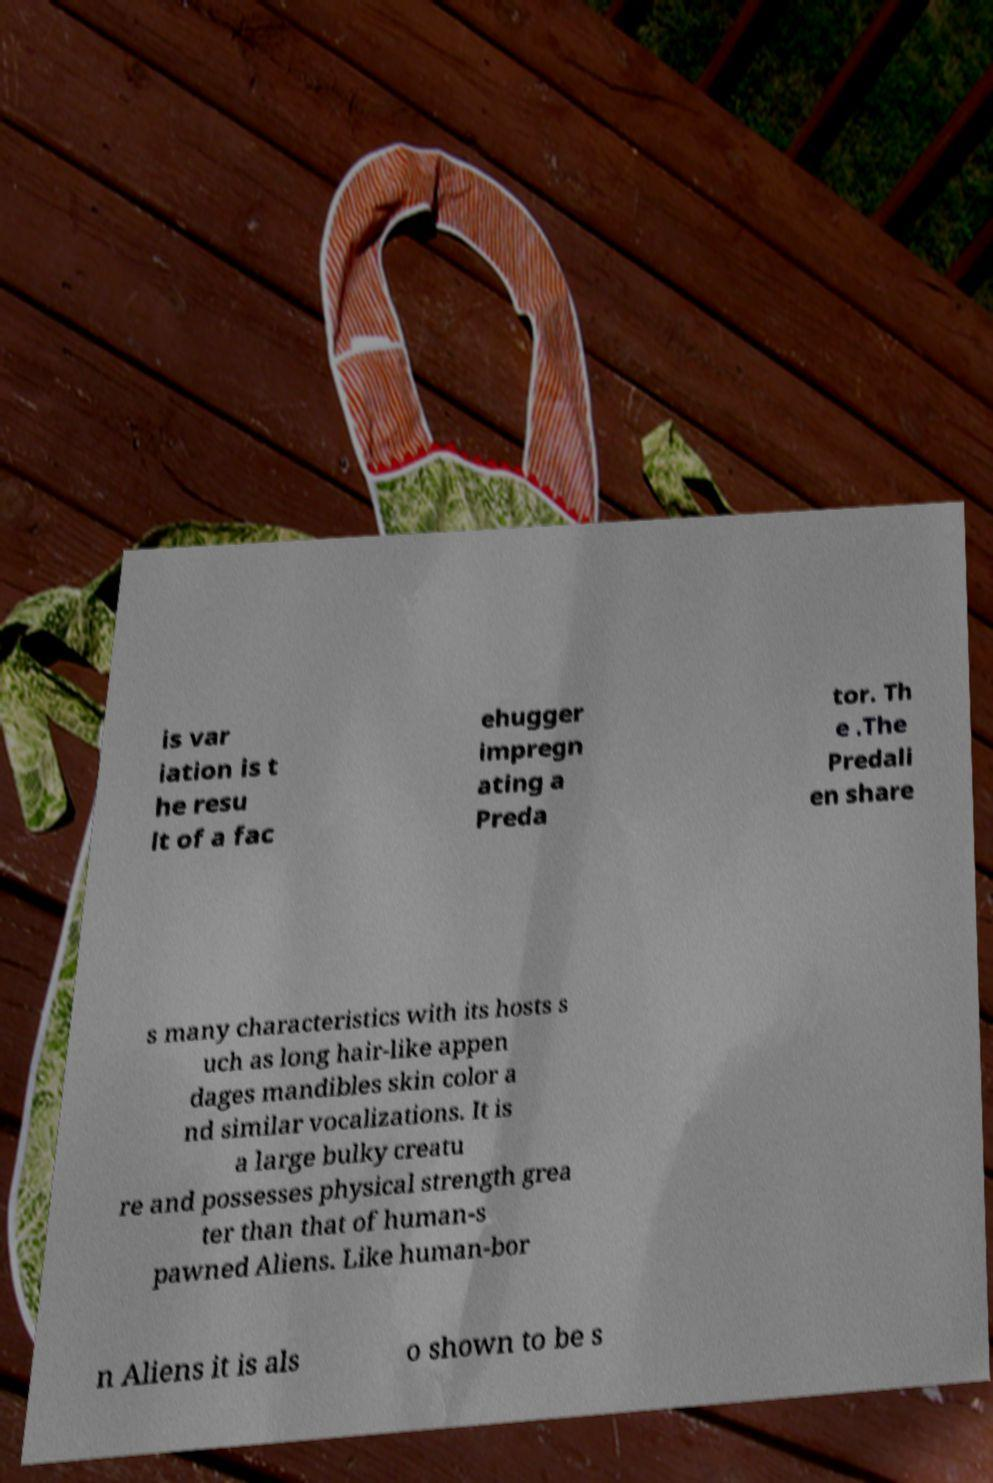There's text embedded in this image that I need extracted. Can you transcribe it verbatim? is var iation is t he resu lt of a fac ehugger impregn ating a Preda tor. Th e .The Predali en share s many characteristics with its hosts s uch as long hair-like appen dages mandibles skin color a nd similar vocalizations. It is a large bulky creatu re and possesses physical strength grea ter than that of human-s pawned Aliens. Like human-bor n Aliens it is als o shown to be s 